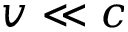<formula> <loc_0><loc_0><loc_500><loc_500>v \ll c</formula> 